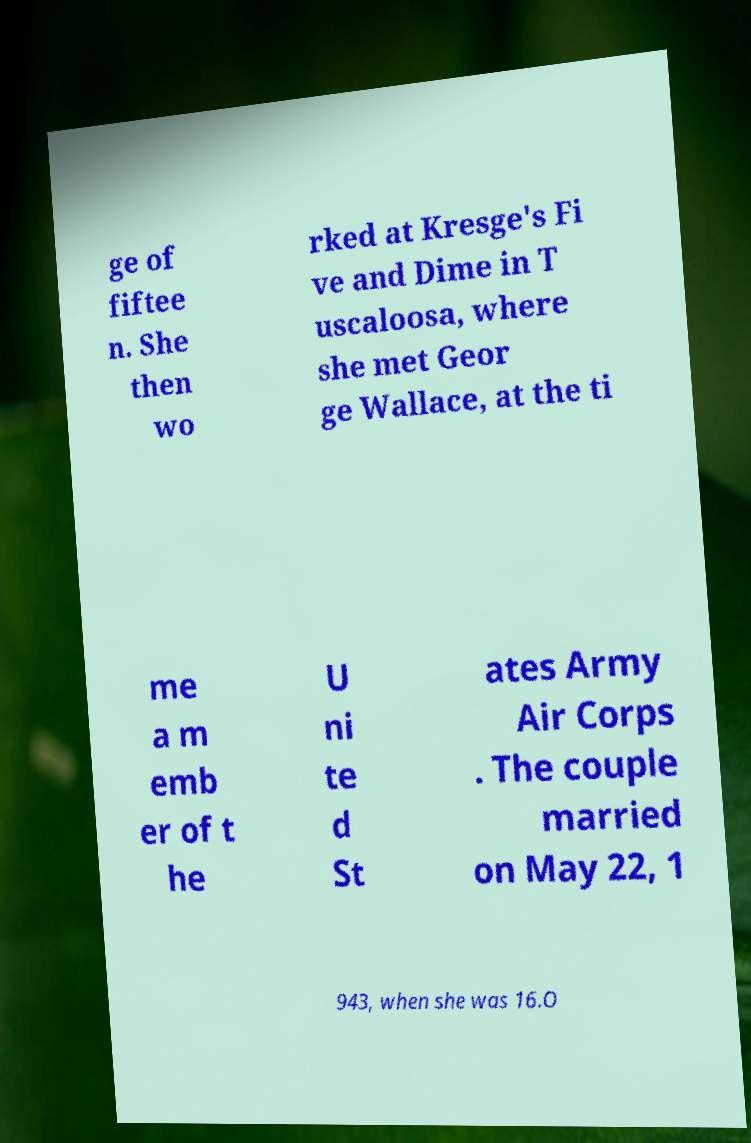For documentation purposes, I need the text within this image transcribed. Could you provide that? ge of fiftee n. She then wo rked at Kresge's Fi ve and Dime in T uscaloosa, where she met Geor ge Wallace, at the ti me a m emb er of t he U ni te d St ates Army Air Corps . The couple married on May 22, 1 943, when she was 16.O 